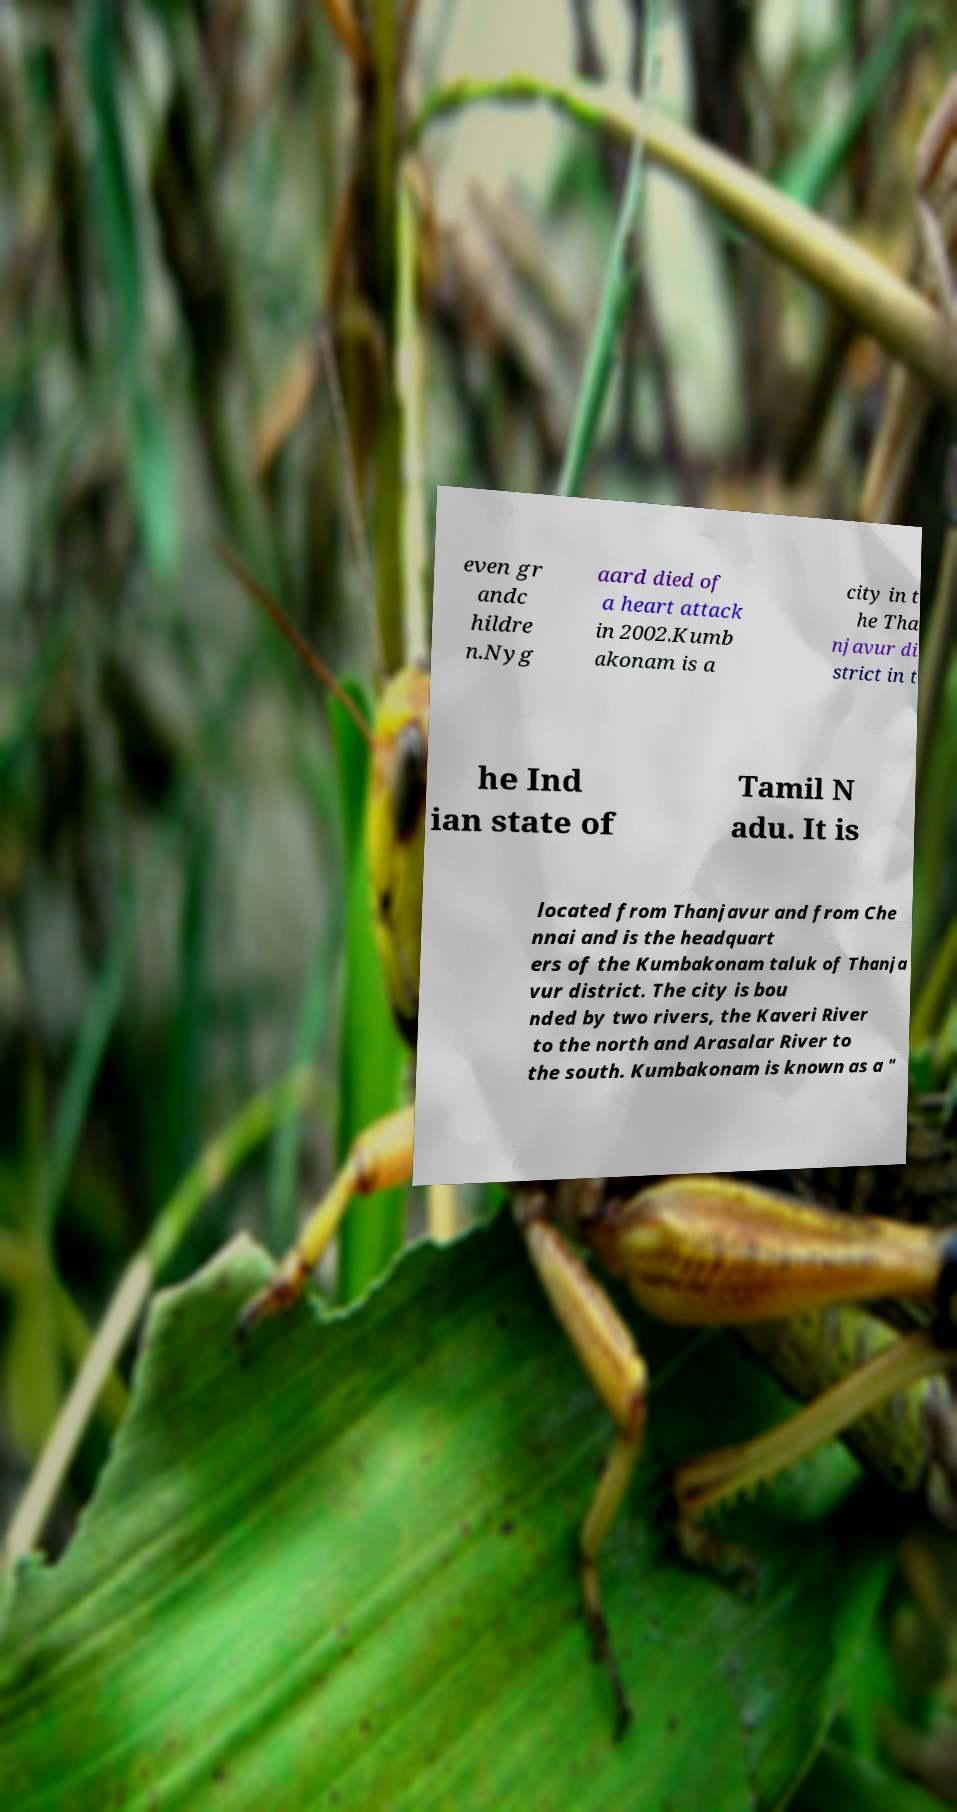Please identify and transcribe the text found in this image. even gr andc hildre n.Nyg aard died of a heart attack in 2002.Kumb akonam is a city in t he Tha njavur di strict in t he Ind ian state of Tamil N adu. It is located from Thanjavur and from Che nnai and is the headquart ers of the Kumbakonam taluk of Thanja vur district. The city is bou nded by two rivers, the Kaveri River to the north and Arasalar River to the south. Kumbakonam is known as a " 